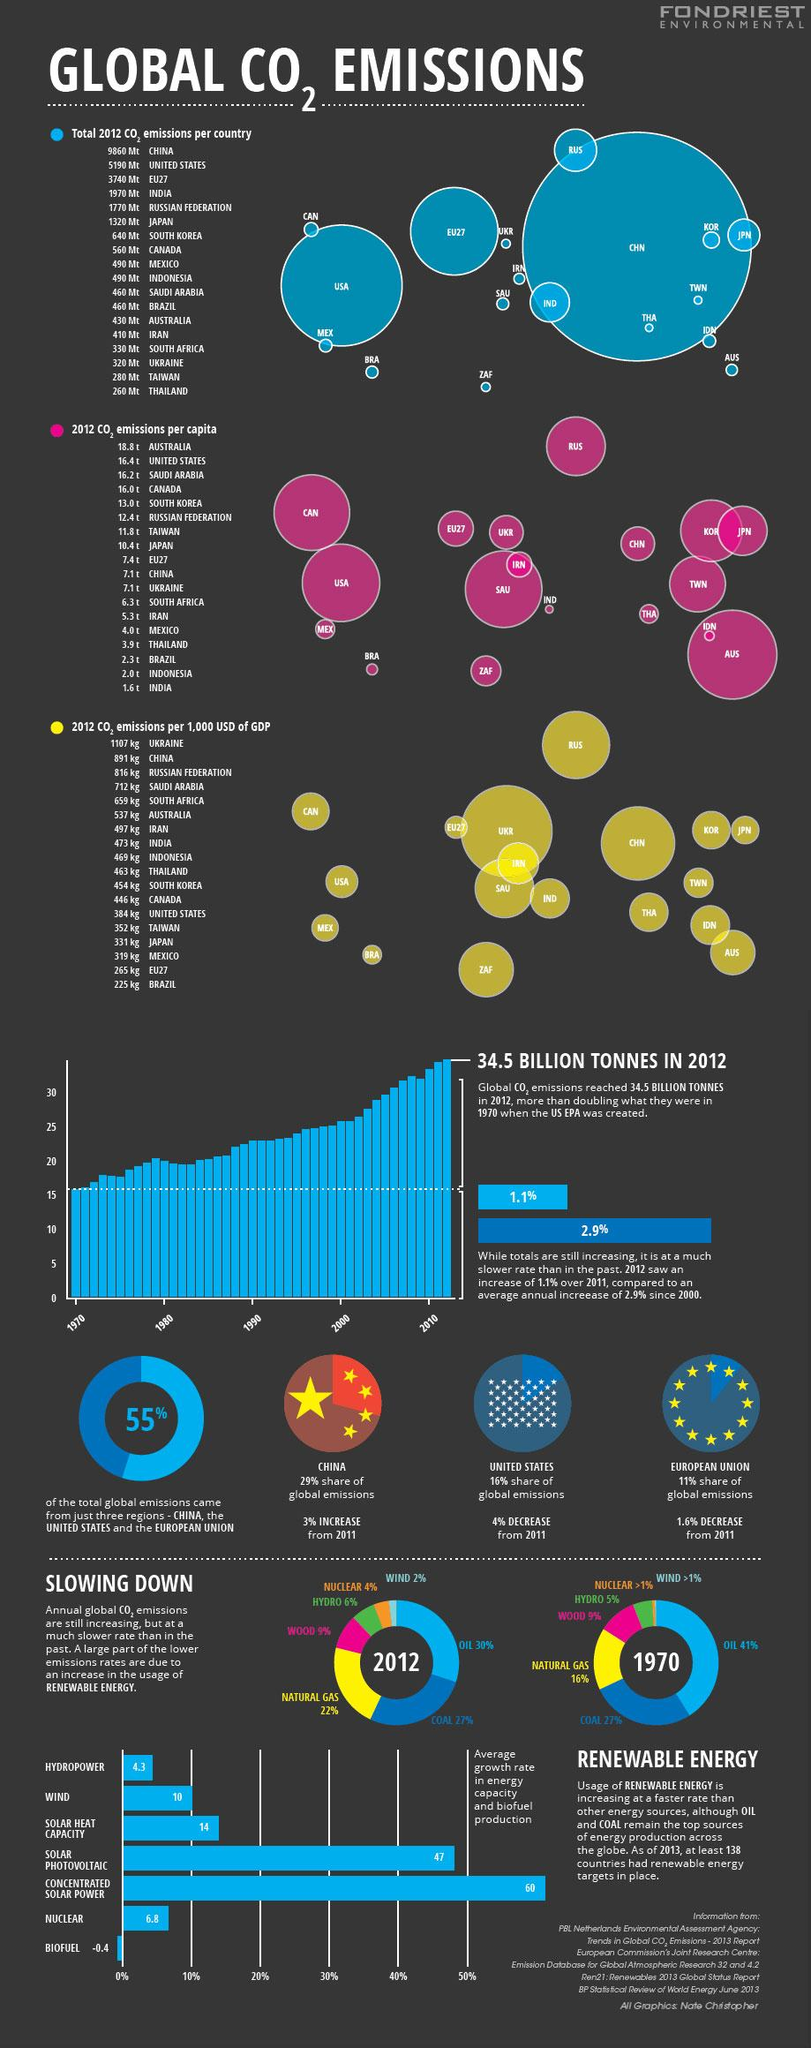List a handful of essential elements in this visual. In 2012, the consumption of oil decreased by approximately 11% compared to 1970. The growth rate of biofuel is negative, making it the renewable energy source with the least growth potential. The country with the highest carbon dioxide emissions is China. In 2012, Mexico and Indonesia were the countries that emitted the equivalent of 490 million metric tons of carbon dioxide. Carbon emissions produced by ZAF per capita are 6.3 tons. 